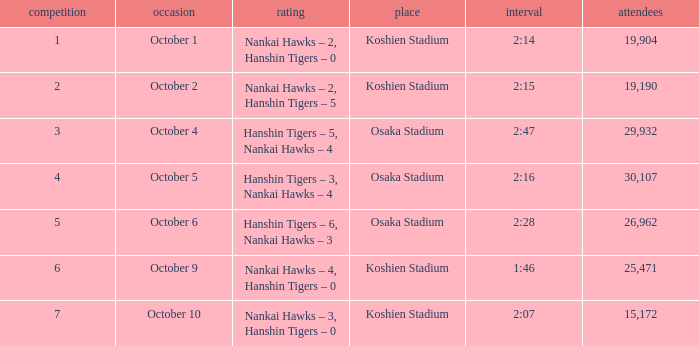How many games had a Time of 2:14? 1.0. 